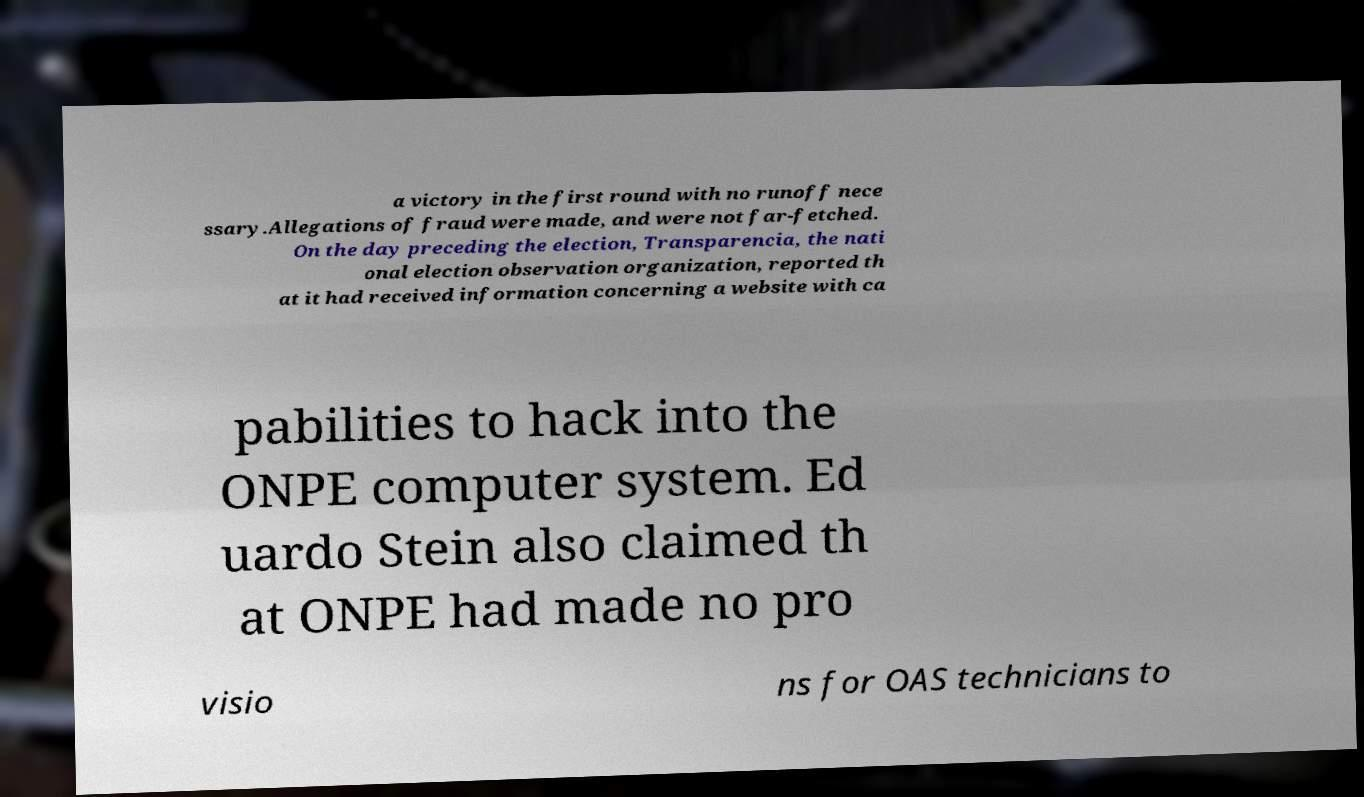Please read and relay the text visible in this image. What does it say? a victory in the first round with no runoff nece ssary.Allegations of fraud were made, and were not far-fetched. On the day preceding the election, Transparencia, the nati onal election observation organization, reported th at it had received information concerning a website with ca pabilities to hack into the ONPE computer system. Ed uardo Stein also claimed th at ONPE had made no pro visio ns for OAS technicians to 